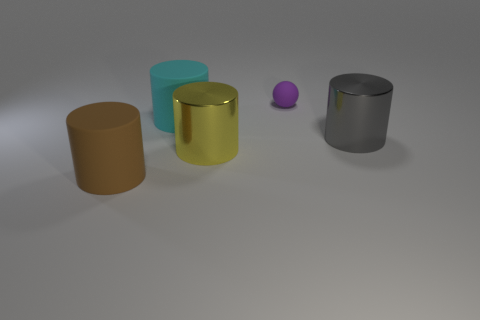Does the matte cylinder behind the brown rubber object have the same color as the cylinder to the right of the yellow metal object?
Make the answer very short. No. How many cyan objects are either rubber things or tiny shiny blocks?
Ensure brevity in your answer.  1. There is a cyan matte thing; is its shape the same as the shiny object that is left of the large gray thing?
Provide a succinct answer. Yes. What is the shape of the cyan thing?
Ensure brevity in your answer.  Cylinder. What material is the gray object that is the same size as the yellow metallic object?
Ensure brevity in your answer.  Metal. Is there anything else that is the same size as the cyan rubber thing?
Offer a terse response. Yes. What number of objects are either purple balls or big things left of the yellow metallic cylinder?
Offer a terse response. 3. There is a brown cylinder that is made of the same material as the purple object; what size is it?
Provide a short and direct response. Large. What shape is the metal object on the left side of the large shiny object behind the big yellow metal cylinder?
Your response must be concise. Cylinder. There is a cylinder that is behind the big yellow object and to the right of the cyan cylinder; what is its size?
Your answer should be compact. Large. 